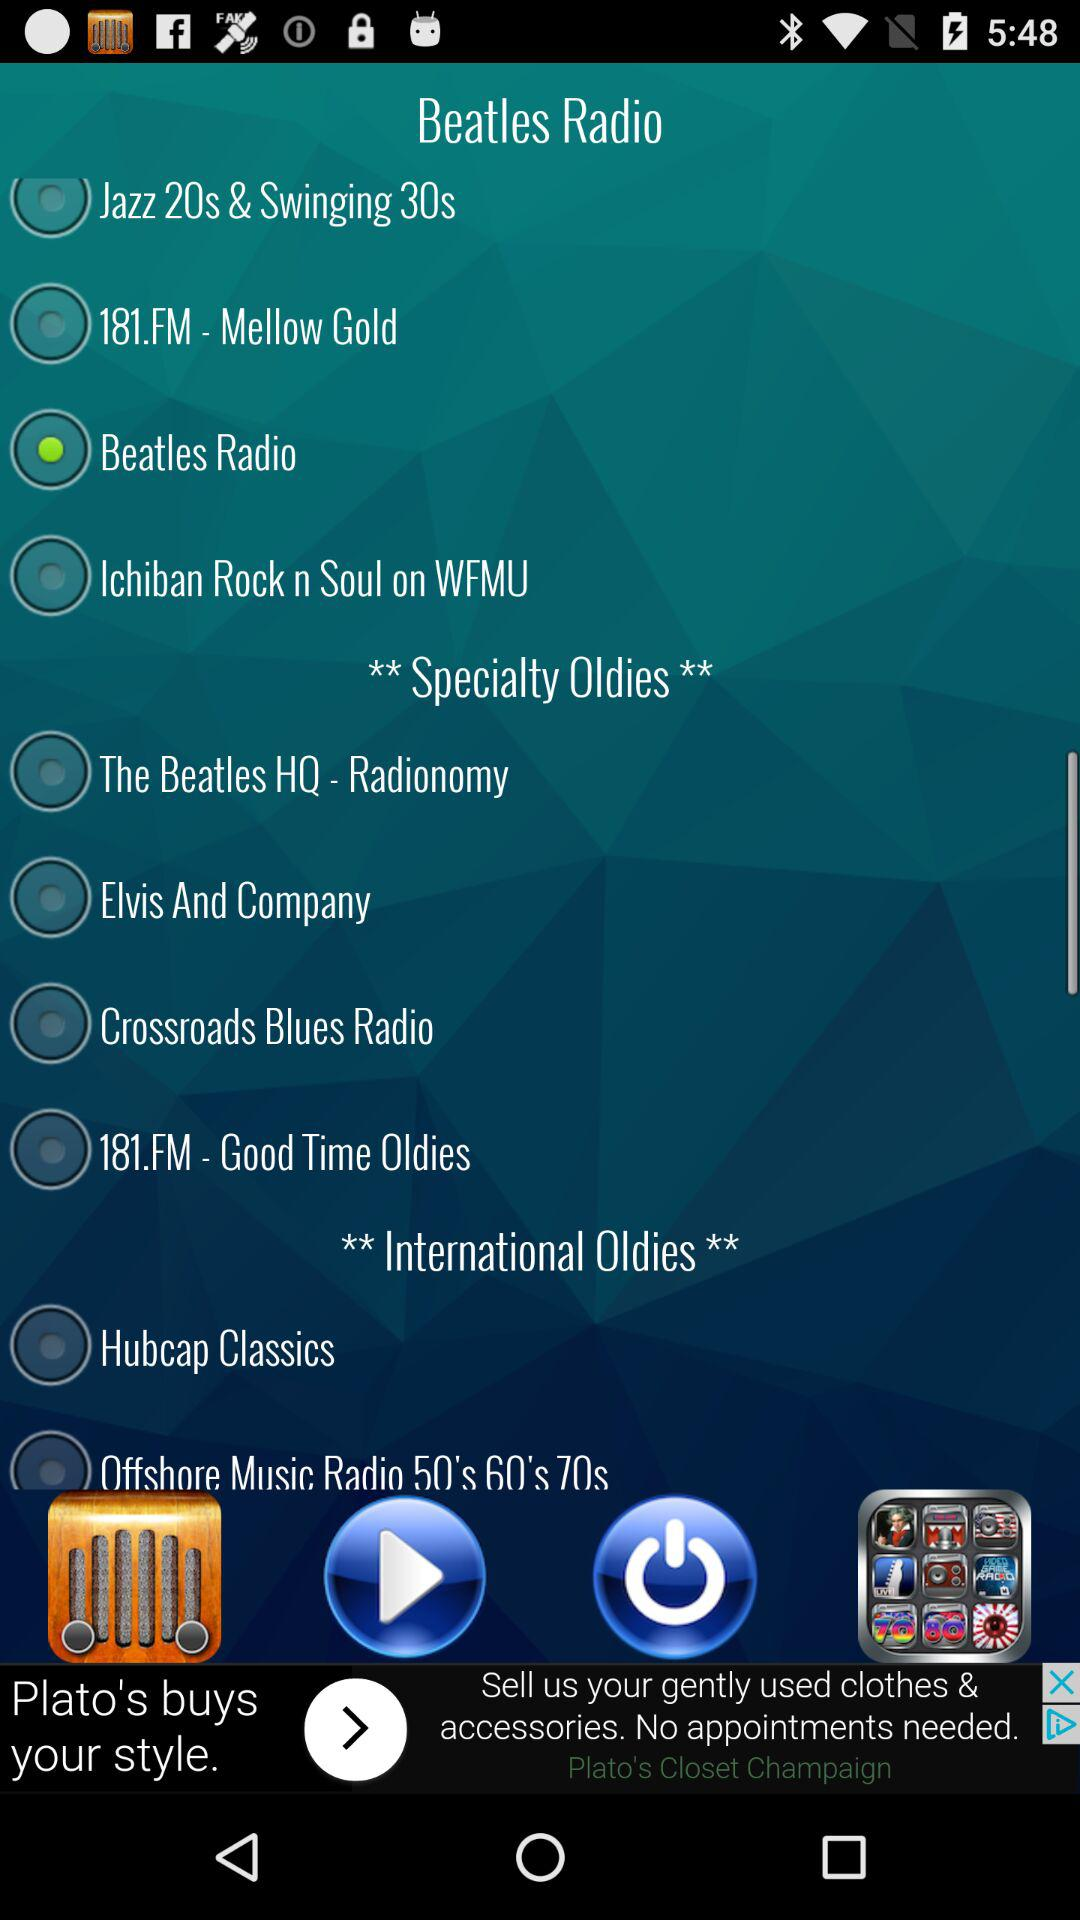Is there any indication of a feature to play or stop the radio stations in this interface? Yes, there is a play button at the bottom of the screen in the center. The play icon suggests you can start streaming a radio station directly from this interface, and likely stop it as well when streaming. 